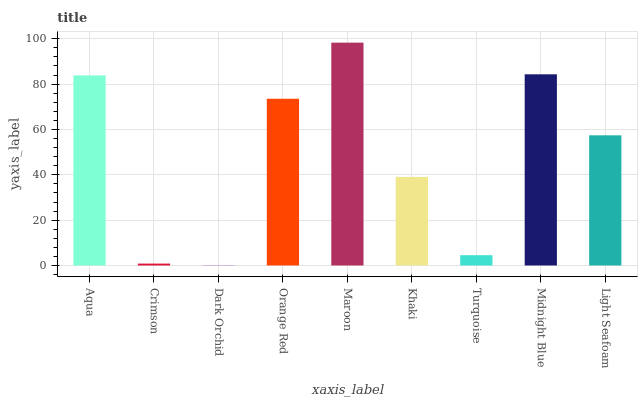Is Dark Orchid the minimum?
Answer yes or no. Yes. Is Maroon the maximum?
Answer yes or no. Yes. Is Crimson the minimum?
Answer yes or no. No. Is Crimson the maximum?
Answer yes or no. No. Is Aqua greater than Crimson?
Answer yes or no. Yes. Is Crimson less than Aqua?
Answer yes or no. Yes. Is Crimson greater than Aqua?
Answer yes or no. No. Is Aqua less than Crimson?
Answer yes or no. No. Is Light Seafoam the high median?
Answer yes or no. Yes. Is Light Seafoam the low median?
Answer yes or no. Yes. Is Turquoise the high median?
Answer yes or no. No. Is Midnight Blue the low median?
Answer yes or no. No. 